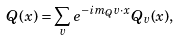<formula> <loc_0><loc_0><loc_500><loc_500>Q ( x ) = \sum _ { v } e ^ { - i m _ { Q } v \cdot x } Q _ { v } ( x ) ,</formula> 